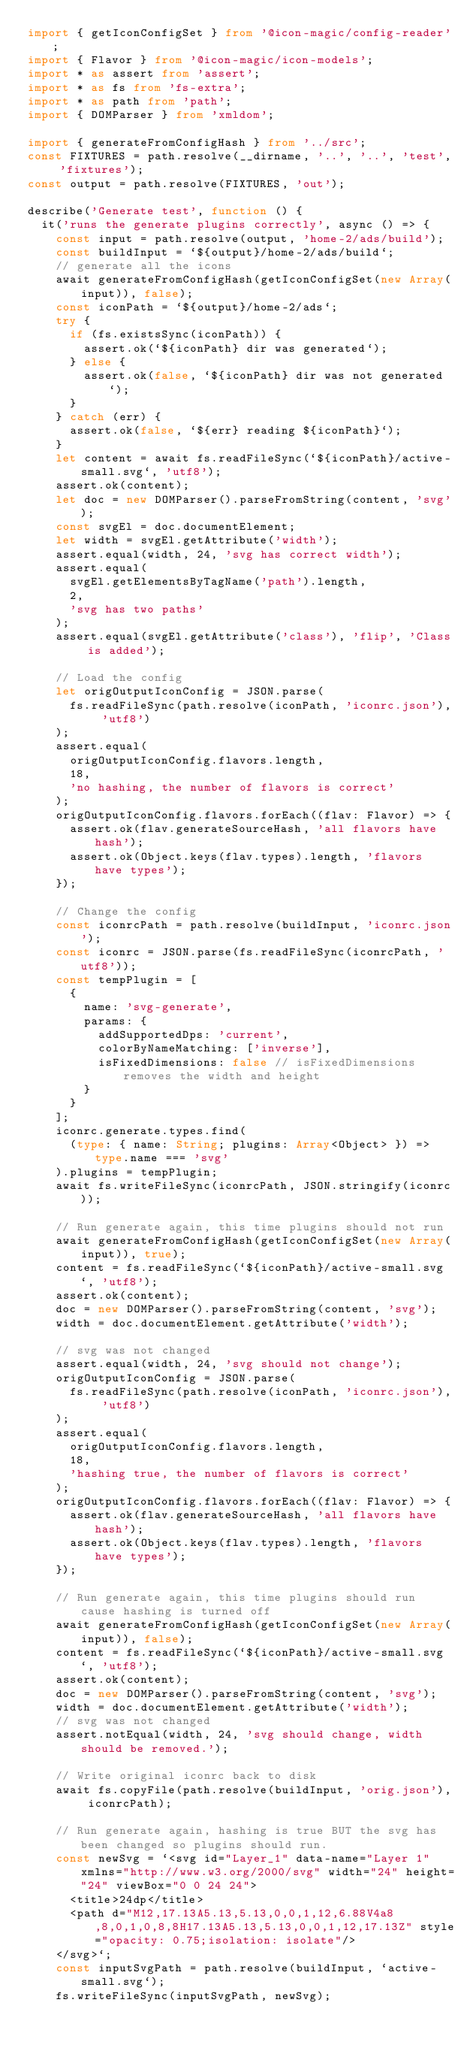<code> <loc_0><loc_0><loc_500><loc_500><_TypeScript_>import { getIconConfigSet } from '@icon-magic/config-reader';
import { Flavor } from '@icon-magic/icon-models';
import * as assert from 'assert';
import * as fs from 'fs-extra';
import * as path from 'path';
import { DOMParser } from 'xmldom';

import { generateFromConfigHash } from '../src';
const FIXTURES = path.resolve(__dirname, '..', '..', 'test', 'fixtures');
const output = path.resolve(FIXTURES, 'out');

describe('Generate test', function () {
  it('runs the generate plugins correctly', async () => {
    const input = path.resolve(output, 'home-2/ads/build');
    const buildInput = `${output}/home-2/ads/build`;
    // generate all the icons
    await generateFromConfigHash(getIconConfigSet(new Array(input)), false);
    const iconPath = `${output}/home-2/ads`;
    try {
      if (fs.existsSync(iconPath)) {
        assert.ok(`${iconPath} dir was generated`);
      } else {
        assert.ok(false, `${iconPath} dir was not generated`);
      }
    } catch (err) {
      assert.ok(false, `${err} reading ${iconPath}`);
    }
    let content = await fs.readFileSync(`${iconPath}/active-small.svg`, 'utf8');
    assert.ok(content);
    let doc = new DOMParser().parseFromString(content, 'svg');
    const svgEl = doc.documentElement;
    let width = svgEl.getAttribute('width');
    assert.equal(width, 24, 'svg has correct width');
    assert.equal(
      svgEl.getElementsByTagName('path').length,
      2,
      'svg has two paths'
    );
    assert.equal(svgEl.getAttribute('class'), 'flip', 'Class is added');

    // Load the config
    let origOutputIconConfig = JSON.parse(
      fs.readFileSync(path.resolve(iconPath, 'iconrc.json'), 'utf8')
    );
    assert.equal(
      origOutputIconConfig.flavors.length,
      18,
      'no hashing, the number of flavors is correct'
    );
    origOutputIconConfig.flavors.forEach((flav: Flavor) => {
      assert.ok(flav.generateSourceHash, 'all flavors have hash');
      assert.ok(Object.keys(flav.types).length, 'flavors have types');
    });

    // Change the config
    const iconrcPath = path.resolve(buildInput, 'iconrc.json');
    const iconrc = JSON.parse(fs.readFileSync(iconrcPath, 'utf8'));
    const tempPlugin = [
      {
        name: 'svg-generate',
        params: {
          addSupportedDps: 'current',
          colorByNameMatching: ['inverse'],
          isFixedDimensions: false // isFixedDimensions removes the width and height
        }
      }
    ];
    iconrc.generate.types.find(
      (type: { name: String; plugins: Array<Object> }) => type.name === 'svg'
    ).plugins = tempPlugin;
    await fs.writeFileSync(iconrcPath, JSON.stringify(iconrc));

    // Run generate again, this time plugins should not run
    await generateFromConfigHash(getIconConfigSet(new Array(input)), true);
    content = fs.readFileSync(`${iconPath}/active-small.svg`, 'utf8');
    assert.ok(content);
    doc = new DOMParser().parseFromString(content, 'svg');
    width = doc.documentElement.getAttribute('width');

    // svg was not changed
    assert.equal(width, 24, 'svg should not change');
    origOutputIconConfig = JSON.parse(
      fs.readFileSync(path.resolve(iconPath, 'iconrc.json'), 'utf8')
    );
    assert.equal(
      origOutputIconConfig.flavors.length,
      18,
      'hashing true, the number of flavors is correct'
    );
    origOutputIconConfig.flavors.forEach((flav: Flavor) => {
      assert.ok(flav.generateSourceHash, 'all flavors have hash');
      assert.ok(Object.keys(flav.types).length, 'flavors have types');
    });

    // Run generate again, this time plugins should run cause hashing is turned off
    await generateFromConfigHash(getIconConfigSet(new Array(input)), false);
    content = fs.readFileSync(`${iconPath}/active-small.svg`, 'utf8');
    assert.ok(content);
    doc = new DOMParser().parseFromString(content, 'svg');
    width = doc.documentElement.getAttribute('width');
    // svg was not changed
    assert.notEqual(width, 24, 'svg should change, width should be removed.');

    // Write original iconrc back to disk
    await fs.copyFile(path.resolve(buildInput, 'orig.json'), iconrcPath);

    // Run generate again, hashing is true BUT the svg has been changed so plugins should run.
    const newSvg = `<svg id="Layer_1" data-name="Layer 1" xmlns="http://www.w3.org/2000/svg" width="24" height="24" viewBox="0 0 24 24">
      <title>24dp</title>
      <path d="M12,17.13A5.13,5.13,0,0,1,12,6.88V4a8,8,0,1,0,8,8H17.13A5.13,5.13,0,0,1,12,17.13Z" style="opacity: 0.75;isolation: isolate"/>
    </svg>`;
    const inputSvgPath = path.resolve(buildInput, `active-small.svg`);
    fs.writeFileSync(inputSvgPath, newSvg);</code> 